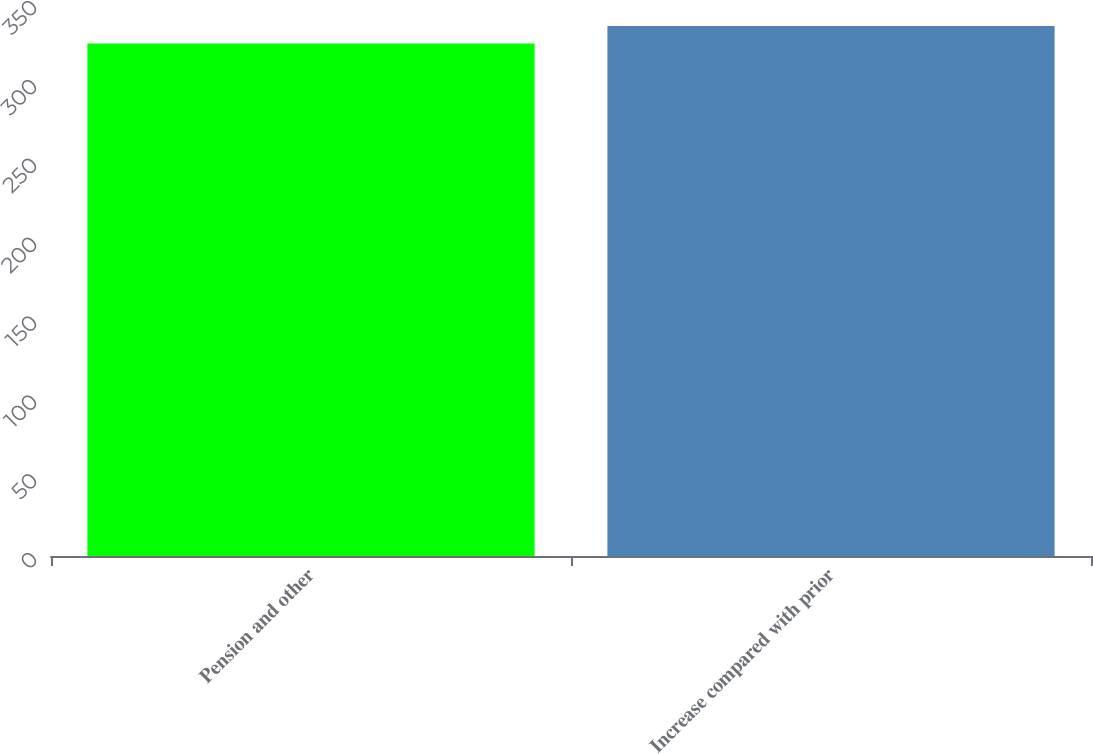Convert chart to OTSL. <chart><loc_0><loc_0><loc_500><loc_500><bar_chart><fcel>Pension and other<fcel>Increase compared with prior<nl><fcel>325<fcel>336<nl></chart> 